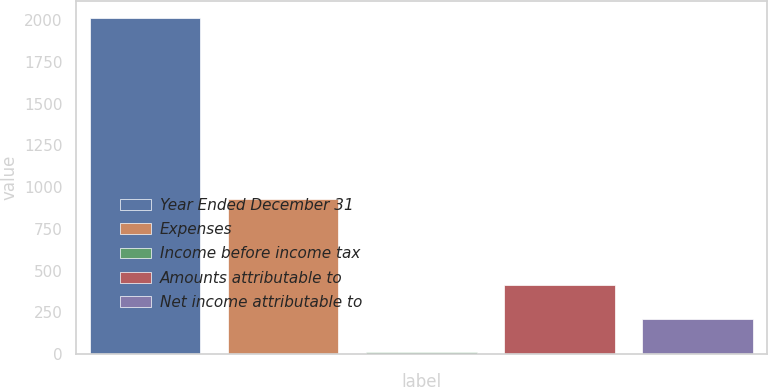Convert chart to OTSL. <chart><loc_0><loc_0><loc_500><loc_500><bar_chart><fcel>Year Ended December 31<fcel>Expenses<fcel>Income before income tax<fcel>Amounts attributable to<fcel>Net income attributable to<nl><fcel>2014<fcel>931<fcel>11<fcel>411.6<fcel>211.3<nl></chart> 